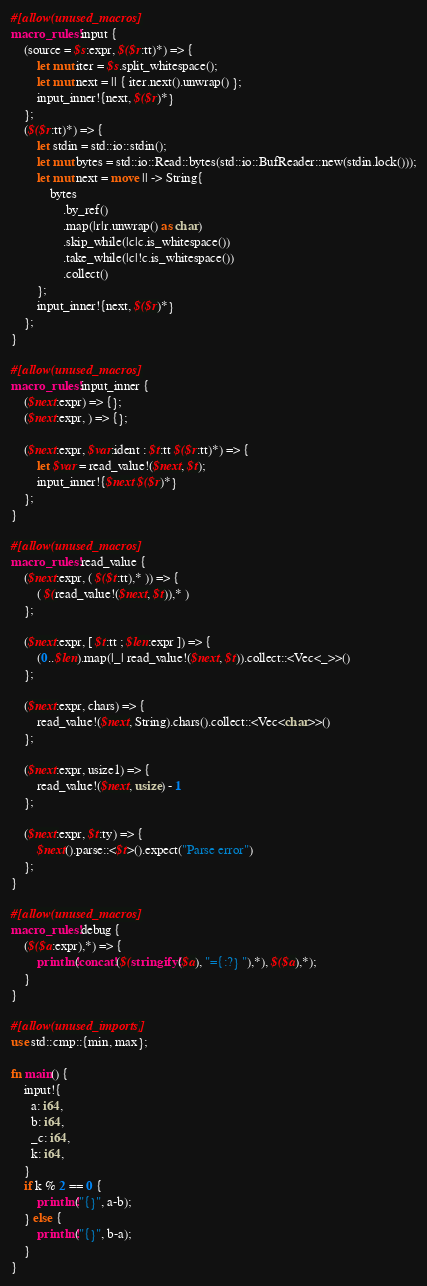Convert code to text. <code><loc_0><loc_0><loc_500><loc_500><_Rust_>#[allow(unused_macros)]
macro_rules! input {
    (source = $s:expr, $($r:tt)*) => {
        let mut iter = $s.split_whitespace();
        let mut next = || { iter.next().unwrap() };
        input_inner!{next, $($r)*}
    };
    ($($r:tt)*) => {
        let stdin = std::io::stdin();
        let mut bytes = std::io::Read::bytes(std::io::BufReader::new(stdin.lock()));
        let mut next = move || -> String{
            bytes
                .by_ref()
                .map(|r|r.unwrap() as char)
                .skip_while(|c|c.is_whitespace())
                .take_while(|c|!c.is_whitespace())
                .collect()
        };
        input_inner!{next, $($r)*}
    };
}

#[allow(unused_macros)]
macro_rules! input_inner {
    ($next:expr) => {};
    ($next:expr, ) => {};

    ($next:expr, $var:ident : $t:tt $($r:tt)*) => {
        let $var = read_value!($next, $t);
        input_inner!{$next $($r)*}
    };
}

#[allow(unused_macros)]
macro_rules! read_value {
    ($next:expr, ( $($t:tt),* )) => {
        ( $(read_value!($next, $t)),* )
    };

    ($next:expr, [ $t:tt ; $len:expr ]) => {
        (0..$len).map(|_| read_value!($next, $t)).collect::<Vec<_>>()
    };

    ($next:expr, chars) => {
        read_value!($next, String).chars().collect::<Vec<char>>()
    };

    ($next:expr, usize1) => {
        read_value!($next, usize) - 1
    };

    ($next:expr, $t:ty) => {
        $next().parse::<$t>().expect("Parse error")
    };
}

#[allow(unused_macros)]
macro_rules! debug {
    ($($a:expr),*) => {
        println!(concat!($(stringify!($a), "={:?} "),*), $($a),*);
    }
}

#[allow(unused_imports)]
use std::cmp::{min, max};

fn main() {
    input!{
      a: i64,
      b: i64,
      _c: i64,
      k: i64,
    }
    if k % 2 == 0 {
        println!("{}", a-b);
    } else {
        println!("{}", b-a);
    }
}
</code> 